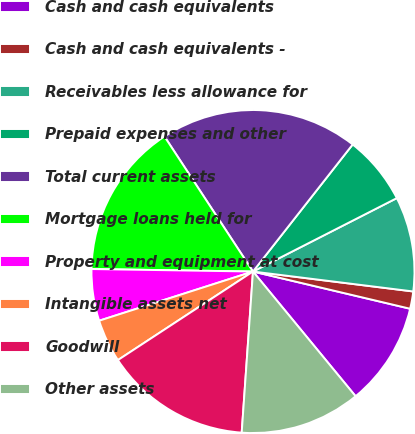<chart> <loc_0><loc_0><loc_500><loc_500><pie_chart><fcel>Cash and cash equivalents<fcel>Cash and cash equivalents -<fcel>Receivables less allowance for<fcel>Prepaid expenses and other<fcel>Total current assets<fcel>Mortgage loans held for<fcel>Property and equipment at cost<fcel>Intangible assets net<fcel>Goodwill<fcel>Other assets<nl><fcel>10.34%<fcel>1.73%<fcel>9.48%<fcel>6.9%<fcel>19.82%<fcel>15.52%<fcel>5.17%<fcel>4.31%<fcel>14.65%<fcel>12.07%<nl></chart> 